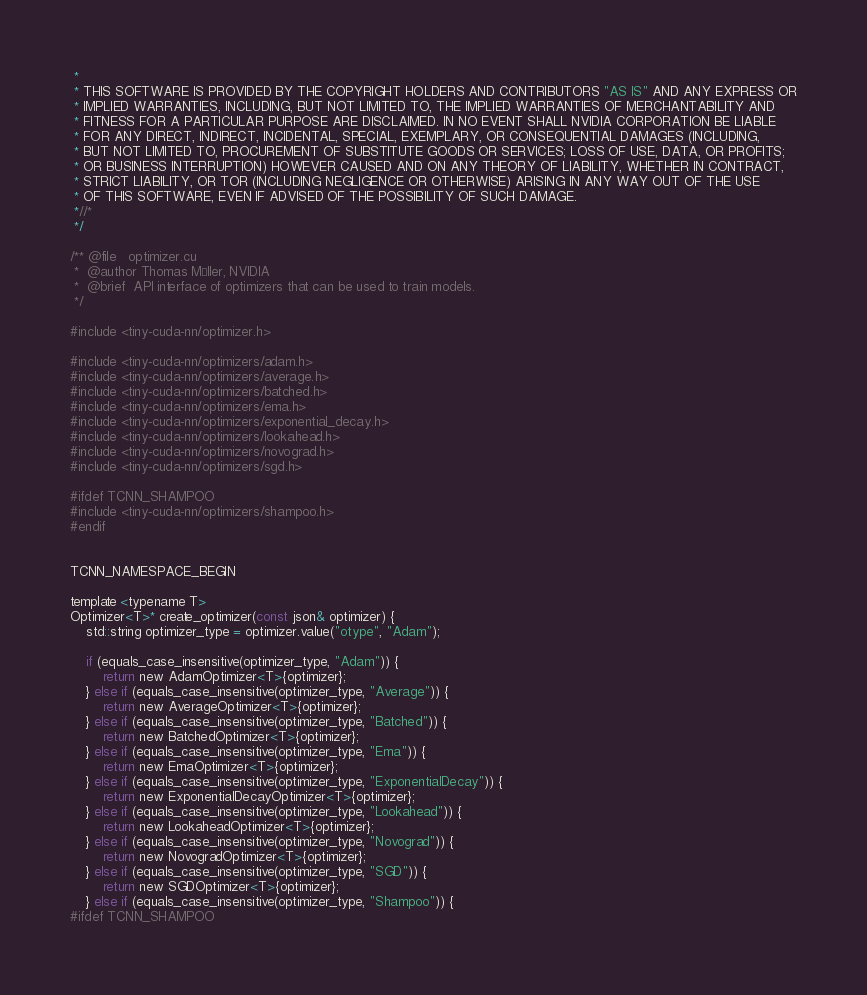<code> <loc_0><loc_0><loc_500><loc_500><_Cuda_> * 
 * THIS SOFTWARE IS PROVIDED BY THE COPYRIGHT HOLDERS AND CONTRIBUTORS "AS IS" AND ANY EXPRESS OR
 * IMPLIED WARRANTIES, INCLUDING, BUT NOT LIMITED TO, THE IMPLIED WARRANTIES OF MERCHANTABILITY AND
 * FITNESS FOR A PARTICULAR PURPOSE ARE DISCLAIMED. IN NO EVENT SHALL NVIDIA CORPORATION BE LIABLE
 * FOR ANY DIRECT, INDIRECT, INCIDENTAL, SPECIAL, EXEMPLARY, OR CONSEQUENTIAL DAMAGES (INCLUDING,
 * BUT NOT LIMITED TO, PROCUREMENT OF SUBSTITUTE GOODS OR SERVICES; LOSS OF USE, DATA, OR PROFITS;
 * OR BUSINESS INTERRUPTION) HOWEVER CAUSED AND ON ANY THEORY OF LIABILITY, WHETHER IN CONTRACT,
 * STRICT LIABILITY, OR TOR (INCLUDING NEGLIGENCE OR OTHERWISE) ARISING IN ANY WAY OUT OF THE USE
 * OF THIS SOFTWARE, EVEN IF ADVISED OF THE POSSIBILITY OF SUCH DAMAGE.
 *//*
 */

/** @file   optimizer.cu
 *  @author Thomas Müller, NVIDIA
 *  @brief  API interface of optimizers that can be used to train models.
 */

#include <tiny-cuda-nn/optimizer.h>

#include <tiny-cuda-nn/optimizers/adam.h>
#include <tiny-cuda-nn/optimizers/average.h>
#include <tiny-cuda-nn/optimizers/batched.h>
#include <tiny-cuda-nn/optimizers/ema.h>
#include <tiny-cuda-nn/optimizers/exponential_decay.h>
#include <tiny-cuda-nn/optimizers/lookahead.h>
#include <tiny-cuda-nn/optimizers/novograd.h>
#include <tiny-cuda-nn/optimizers/sgd.h>

#ifdef TCNN_SHAMPOO
#include <tiny-cuda-nn/optimizers/shampoo.h>
#endif


TCNN_NAMESPACE_BEGIN

template <typename T>
Optimizer<T>* create_optimizer(const json& optimizer) {
	std::string optimizer_type = optimizer.value("otype", "Adam");

	if (equals_case_insensitive(optimizer_type, "Adam")) {
		return new AdamOptimizer<T>{optimizer};
	} else if (equals_case_insensitive(optimizer_type, "Average")) {
		return new AverageOptimizer<T>{optimizer};
	} else if (equals_case_insensitive(optimizer_type, "Batched")) {
		return new BatchedOptimizer<T>{optimizer};
	} else if (equals_case_insensitive(optimizer_type, "Ema")) {
		return new EmaOptimizer<T>{optimizer};
	} else if (equals_case_insensitive(optimizer_type, "ExponentialDecay")) {
		return new ExponentialDecayOptimizer<T>{optimizer};
	} else if (equals_case_insensitive(optimizer_type, "Lookahead")) {
		return new LookaheadOptimizer<T>{optimizer};
	} else if (equals_case_insensitive(optimizer_type, "Novograd")) {
		return new NovogradOptimizer<T>{optimizer};
	} else if (equals_case_insensitive(optimizer_type, "SGD")) {
		return new SGDOptimizer<T>{optimizer};
	} else if (equals_case_insensitive(optimizer_type, "Shampoo")) {
#ifdef TCNN_SHAMPOO</code> 